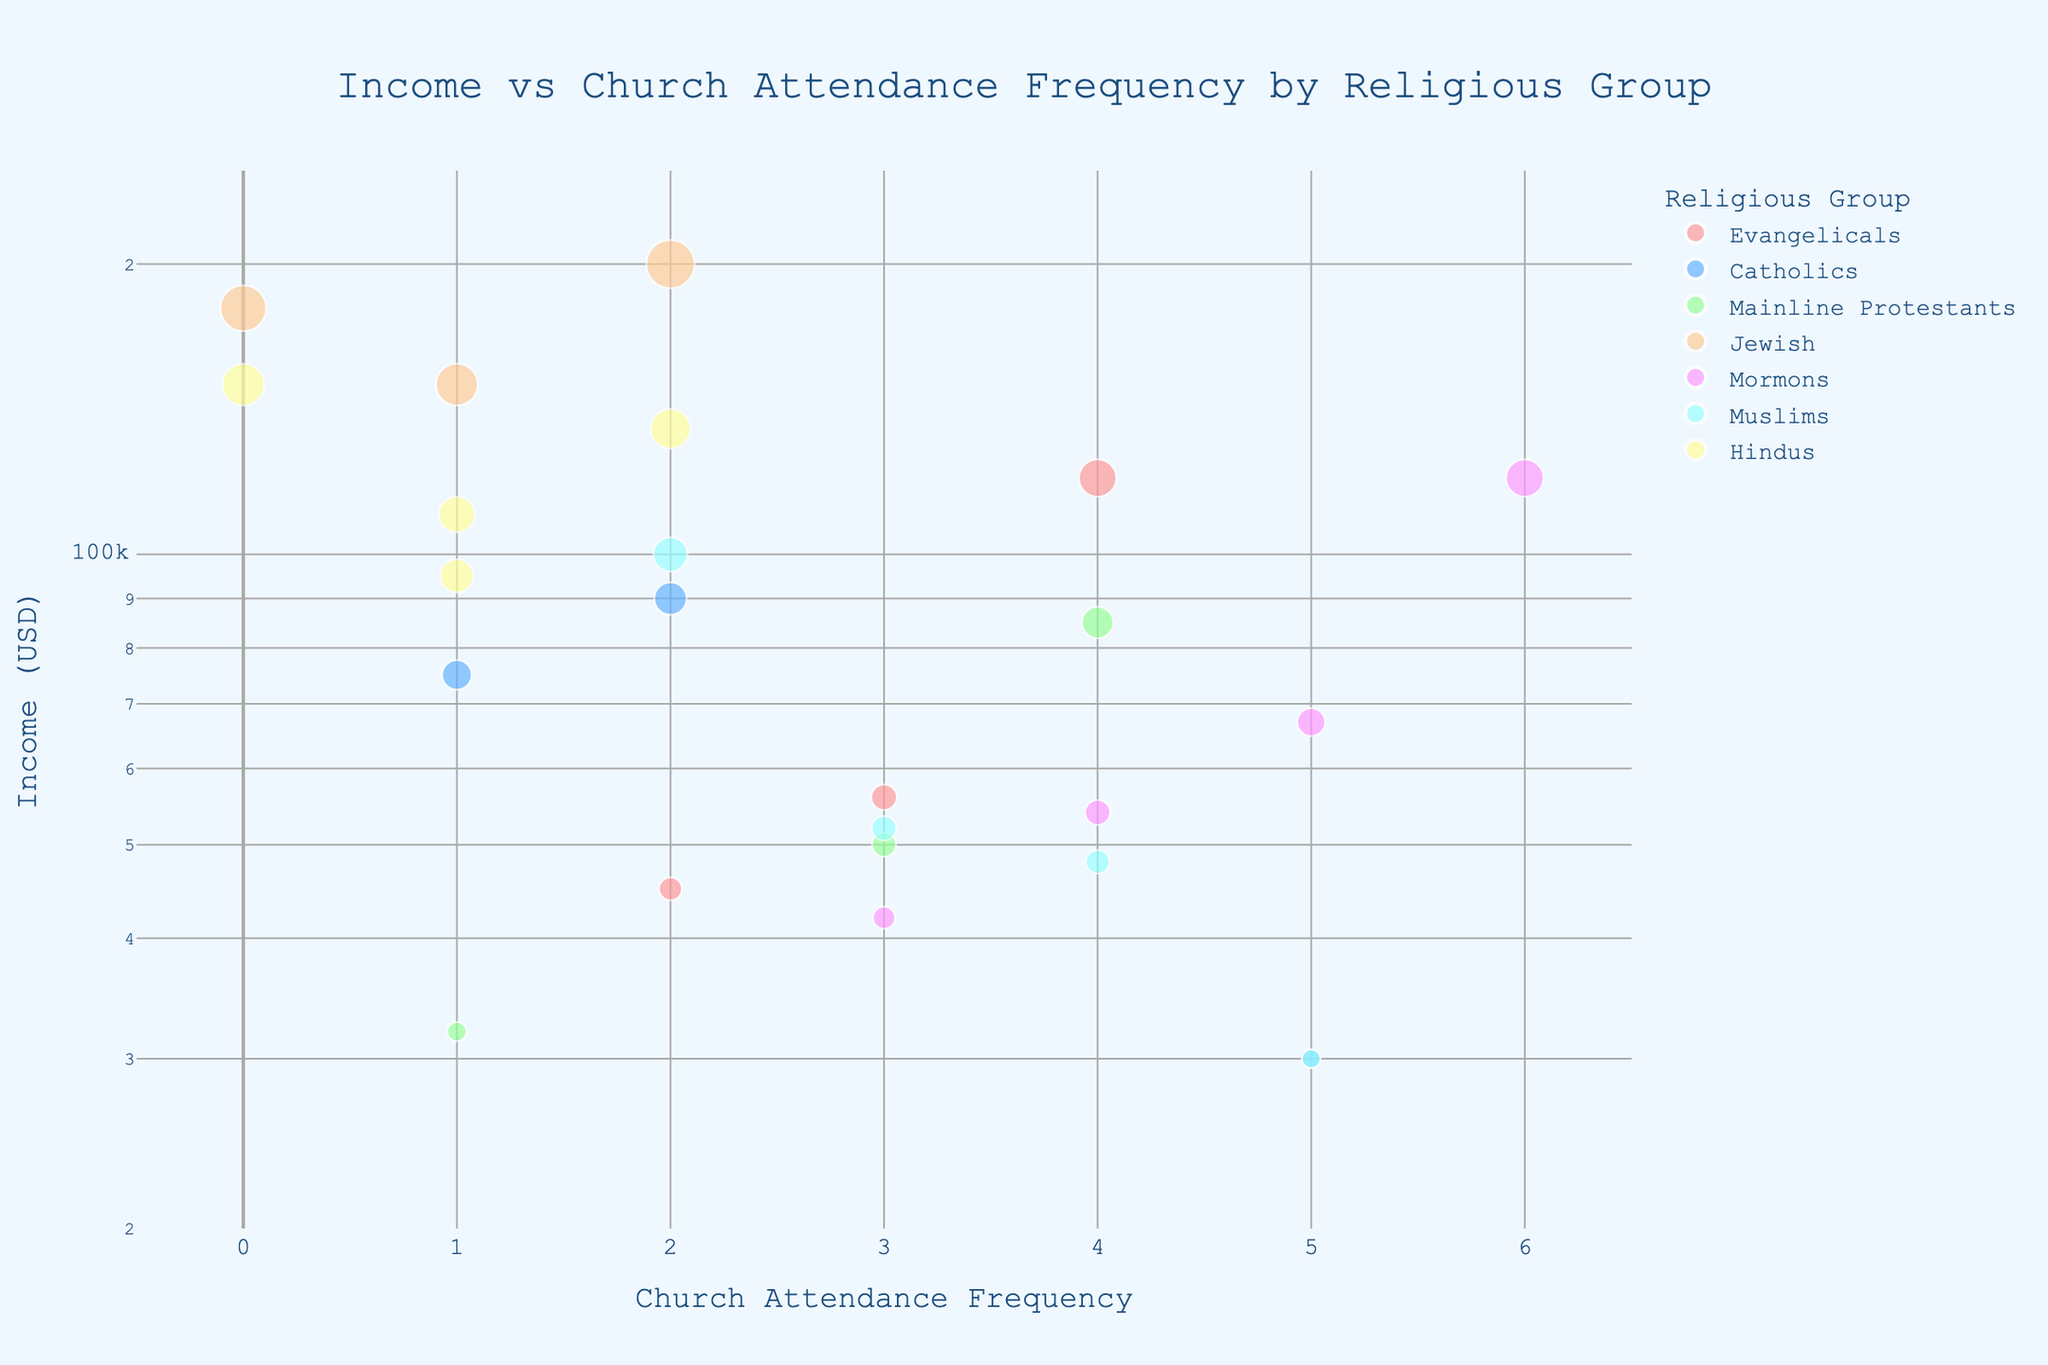What's the title of the plot? The title is prominently displayed at the top center of the plot.
Answer: "Income vs Church Attendance Frequency by Religious Group" How is the y-axis scaled? The y-axis is scaled logarithmically as indicated by the 'log_y=True' setting in the code and can be inferred by observing the unevenly spaced tick marks.
Answer: Logarithmic scale Which religious group has the highest income data point? The highest income data point corresponds to the Jewish group, as seen by the data points clustered near the upper end of the income axis.
Answer: Jewish Which religious group attends church most frequently? The Mormons have the highest church attendance frequency, shown by the data point at 'Church Attendance Frequency' = 6.
Answer: Mormons Which religious group has the lowest income data point? By looking at the lower end of the income scale, the data point for Catholics is the lowest, as their point is closest to the bottom of the y-axis.
Answer: Catholics What is the income range for the Hindu group? The Hindu group has income data points ranging from $95,000 to $150,000, which can be determined by observing the y-axis positions of the Hindu data points.
Answer: $95,000 to $150,000 Identify a group that has a wide range of church attendance frequencies. Mormons have the widest range of church attendance frequencies, from 3 to 6.
Answer: Mormons How does Catholic income distribution compare to Evangelical's? Catholics have a wider income distribution ($30,000 to $90,000) compared to Evangelicals ($45,000 to $120,000) but overlap significantly in middle and lower income areas.
Answer: Catholics have a wider range at lower incomes Which group has the least variation in church attendance frequency? Hindus have the least variation, with data points closely clustered around frequencies of 0, 1, and 2.
Answer: Hindus 